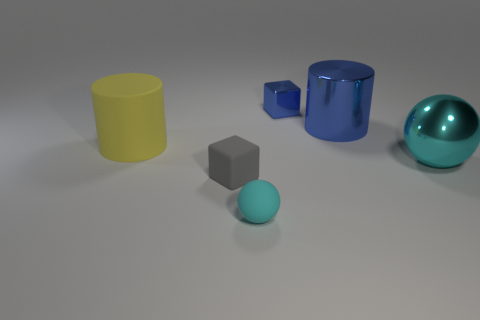Add 3 yellow matte cylinders. How many objects exist? 9 Add 1 tiny blue blocks. How many tiny blue blocks are left? 2 Add 1 small green shiny cylinders. How many small green shiny cylinders exist? 1 Subtract 0 brown cylinders. How many objects are left? 6 Subtract all cubes. How many objects are left? 4 Subtract all red cylinders. Subtract all purple balls. How many cylinders are left? 2 Subtract all small gray spheres. Subtract all big cyan spheres. How many objects are left? 5 